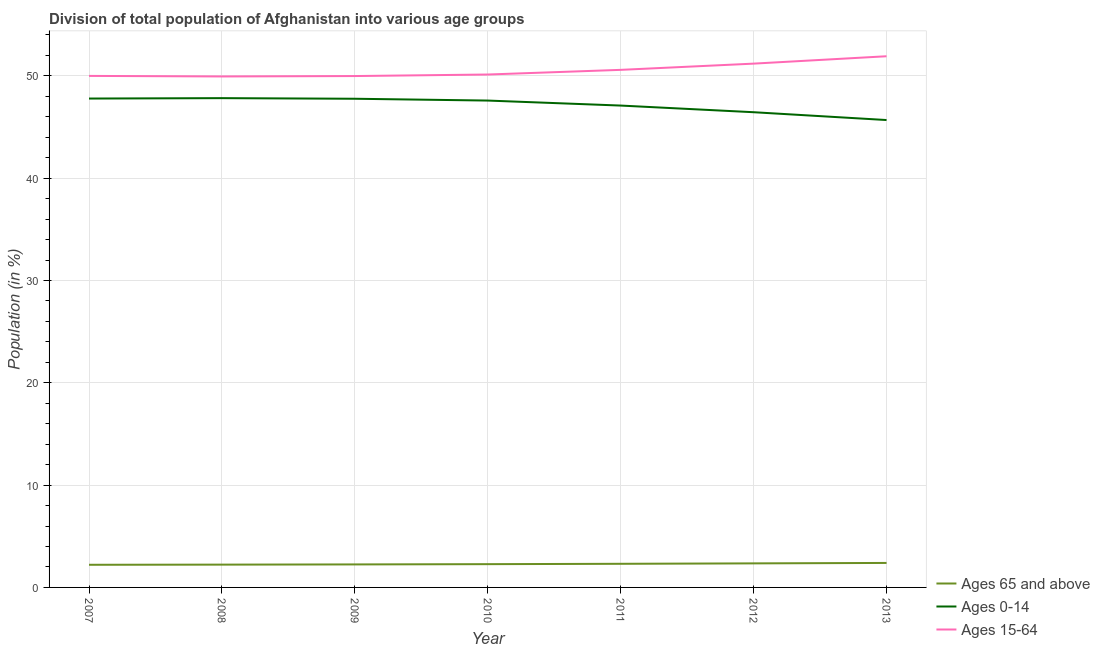How many different coloured lines are there?
Make the answer very short. 3. Does the line corresponding to percentage of population within the age-group of 65 and above intersect with the line corresponding to percentage of population within the age-group 15-64?
Provide a succinct answer. No. Is the number of lines equal to the number of legend labels?
Keep it short and to the point. Yes. What is the percentage of population within the age-group 15-64 in 2007?
Keep it short and to the point. 50. Across all years, what is the maximum percentage of population within the age-group of 65 and above?
Ensure brevity in your answer.  2.39. Across all years, what is the minimum percentage of population within the age-group of 65 and above?
Make the answer very short. 2.21. In which year was the percentage of population within the age-group of 65 and above minimum?
Offer a terse response. 2007. What is the total percentage of population within the age-group 15-64 in the graph?
Provide a short and direct response. 353.78. What is the difference between the percentage of population within the age-group 15-64 in 2009 and that in 2011?
Your answer should be very brief. -0.61. What is the difference between the percentage of population within the age-group 15-64 in 2012 and the percentage of population within the age-group 0-14 in 2010?
Your answer should be very brief. 3.61. What is the average percentage of population within the age-group 0-14 per year?
Your answer should be compact. 47.17. In the year 2011, what is the difference between the percentage of population within the age-group of 65 and above and percentage of population within the age-group 15-64?
Provide a short and direct response. -48.28. In how many years, is the percentage of population within the age-group 0-14 greater than 30 %?
Offer a terse response. 7. What is the ratio of the percentage of population within the age-group 0-14 in 2009 to that in 2012?
Offer a terse response. 1.03. Is the percentage of population within the age-group 0-14 in 2009 less than that in 2011?
Offer a terse response. No. Is the difference between the percentage of population within the age-group of 65 and above in 2007 and 2008 greater than the difference between the percentage of population within the age-group 15-64 in 2007 and 2008?
Give a very brief answer. No. What is the difference between the highest and the second highest percentage of population within the age-group 0-14?
Give a very brief answer. 0.04. What is the difference between the highest and the lowest percentage of population within the age-group of 65 and above?
Offer a terse response. 0.18. In how many years, is the percentage of population within the age-group of 65 and above greater than the average percentage of population within the age-group of 65 and above taken over all years?
Provide a succinct answer. 3. Is the sum of the percentage of population within the age-group 15-64 in 2010 and 2011 greater than the maximum percentage of population within the age-group 0-14 across all years?
Keep it short and to the point. Yes. Is it the case that in every year, the sum of the percentage of population within the age-group of 65 and above and percentage of population within the age-group 0-14 is greater than the percentage of population within the age-group 15-64?
Provide a succinct answer. No. Is the percentage of population within the age-group of 65 and above strictly greater than the percentage of population within the age-group 15-64 over the years?
Provide a short and direct response. No. How many lines are there?
Your answer should be compact. 3. How many years are there in the graph?
Provide a short and direct response. 7. Are the values on the major ticks of Y-axis written in scientific E-notation?
Keep it short and to the point. No. Does the graph contain any zero values?
Give a very brief answer. No. Where does the legend appear in the graph?
Provide a succinct answer. Bottom right. What is the title of the graph?
Offer a very short reply. Division of total population of Afghanistan into various age groups
. Does "Tertiary education" appear as one of the legend labels in the graph?
Provide a short and direct response. No. What is the label or title of the X-axis?
Your answer should be compact. Year. What is the label or title of the Y-axis?
Your answer should be very brief. Population (in %). What is the Population (in %) in Ages 65 and above in 2007?
Provide a succinct answer. 2.21. What is the Population (in %) in Ages 0-14 in 2007?
Provide a succinct answer. 47.79. What is the Population (in %) of Ages 15-64 in 2007?
Offer a very short reply. 50. What is the Population (in %) in Ages 65 and above in 2008?
Offer a terse response. 2.23. What is the Population (in %) of Ages 0-14 in 2008?
Your answer should be very brief. 47.83. What is the Population (in %) of Ages 15-64 in 2008?
Provide a short and direct response. 49.95. What is the Population (in %) of Ages 65 and above in 2009?
Your answer should be compact. 2.25. What is the Population (in %) in Ages 0-14 in 2009?
Give a very brief answer. 47.77. What is the Population (in %) in Ages 15-64 in 2009?
Make the answer very short. 49.98. What is the Population (in %) of Ages 65 and above in 2010?
Keep it short and to the point. 2.28. What is the Population (in %) of Ages 0-14 in 2010?
Provide a succinct answer. 47.59. What is the Population (in %) in Ages 15-64 in 2010?
Give a very brief answer. 50.14. What is the Population (in %) of Ages 65 and above in 2011?
Your response must be concise. 2.31. What is the Population (in %) of Ages 0-14 in 2011?
Make the answer very short. 47.1. What is the Population (in %) in Ages 15-64 in 2011?
Provide a short and direct response. 50.59. What is the Population (in %) in Ages 65 and above in 2012?
Make the answer very short. 2.35. What is the Population (in %) in Ages 0-14 in 2012?
Provide a short and direct response. 46.45. What is the Population (in %) of Ages 15-64 in 2012?
Your answer should be compact. 51.2. What is the Population (in %) in Ages 65 and above in 2013?
Offer a very short reply. 2.39. What is the Population (in %) in Ages 0-14 in 2013?
Ensure brevity in your answer.  45.69. What is the Population (in %) in Ages 15-64 in 2013?
Your response must be concise. 51.92. Across all years, what is the maximum Population (in %) of Ages 65 and above?
Ensure brevity in your answer.  2.39. Across all years, what is the maximum Population (in %) of Ages 0-14?
Your response must be concise. 47.83. Across all years, what is the maximum Population (in %) in Ages 15-64?
Your answer should be compact. 51.92. Across all years, what is the minimum Population (in %) of Ages 65 and above?
Keep it short and to the point. 2.21. Across all years, what is the minimum Population (in %) of Ages 0-14?
Give a very brief answer. 45.69. Across all years, what is the minimum Population (in %) in Ages 15-64?
Provide a short and direct response. 49.95. What is the total Population (in %) of Ages 65 and above in the graph?
Provide a succinct answer. 16.02. What is the total Population (in %) of Ages 0-14 in the graph?
Your answer should be compact. 330.2. What is the total Population (in %) in Ages 15-64 in the graph?
Make the answer very short. 353.78. What is the difference between the Population (in %) of Ages 65 and above in 2007 and that in 2008?
Give a very brief answer. -0.02. What is the difference between the Population (in %) in Ages 0-14 in 2007 and that in 2008?
Ensure brevity in your answer.  -0.04. What is the difference between the Population (in %) of Ages 15-64 in 2007 and that in 2008?
Ensure brevity in your answer.  0.05. What is the difference between the Population (in %) in Ages 65 and above in 2007 and that in 2009?
Provide a short and direct response. -0.04. What is the difference between the Population (in %) of Ages 0-14 in 2007 and that in 2009?
Offer a very short reply. 0.02. What is the difference between the Population (in %) in Ages 15-64 in 2007 and that in 2009?
Offer a terse response. 0.01. What is the difference between the Population (in %) in Ages 65 and above in 2007 and that in 2010?
Keep it short and to the point. -0.06. What is the difference between the Population (in %) in Ages 0-14 in 2007 and that in 2010?
Your answer should be very brief. 0.2. What is the difference between the Population (in %) of Ages 15-64 in 2007 and that in 2010?
Provide a succinct answer. -0.14. What is the difference between the Population (in %) of Ages 65 and above in 2007 and that in 2011?
Keep it short and to the point. -0.1. What is the difference between the Population (in %) of Ages 0-14 in 2007 and that in 2011?
Provide a short and direct response. 0.69. What is the difference between the Population (in %) of Ages 15-64 in 2007 and that in 2011?
Your answer should be compact. -0.59. What is the difference between the Population (in %) in Ages 65 and above in 2007 and that in 2012?
Make the answer very short. -0.14. What is the difference between the Population (in %) of Ages 0-14 in 2007 and that in 2012?
Provide a succinct answer. 1.34. What is the difference between the Population (in %) in Ages 65 and above in 2007 and that in 2013?
Keep it short and to the point. -0.18. What is the difference between the Population (in %) in Ages 0-14 in 2007 and that in 2013?
Provide a succinct answer. 2.1. What is the difference between the Population (in %) in Ages 15-64 in 2007 and that in 2013?
Offer a terse response. -1.92. What is the difference between the Population (in %) in Ages 65 and above in 2008 and that in 2009?
Keep it short and to the point. -0.02. What is the difference between the Population (in %) in Ages 0-14 in 2008 and that in 2009?
Provide a short and direct response. 0.06. What is the difference between the Population (in %) in Ages 15-64 in 2008 and that in 2009?
Offer a terse response. -0.04. What is the difference between the Population (in %) in Ages 65 and above in 2008 and that in 2010?
Give a very brief answer. -0.05. What is the difference between the Population (in %) in Ages 0-14 in 2008 and that in 2010?
Keep it short and to the point. 0.24. What is the difference between the Population (in %) in Ages 15-64 in 2008 and that in 2010?
Your answer should be compact. -0.19. What is the difference between the Population (in %) of Ages 65 and above in 2008 and that in 2011?
Make the answer very short. -0.08. What is the difference between the Population (in %) of Ages 0-14 in 2008 and that in 2011?
Offer a very short reply. 0.72. What is the difference between the Population (in %) of Ages 15-64 in 2008 and that in 2011?
Provide a short and direct response. -0.64. What is the difference between the Population (in %) in Ages 65 and above in 2008 and that in 2012?
Provide a succinct answer. -0.12. What is the difference between the Population (in %) in Ages 0-14 in 2008 and that in 2012?
Give a very brief answer. 1.38. What is the difference between the Population (in %) of Ages 15-64 in 2008 and that in 2012?
Make the answer very short. -1.25. What is the difference between the Population (in %) of Ages 65 and above in 2008 and that in 2013?
Offer a terse response. -0.17. What is the difference between the Population (in %) of Ages 0-14 in 2008 and that in 2013?
Keep it short and to the point. 2.14. What is the difference between the Population (in %) of Ages 15-64 in 2008 and that in 2013?
Your response must be concise. -1.97. What is the difference between the Population (in %) of Ages 65 and above in 2009 and that in 2010?
Your response must be concise. -0.03. What is the difference between the Population (in %) in Ages 0-14 in 2009 and that in 2010?
Offer a very short reply. 0.18. What is the difference between the Population (in %) in Ages 15-64 in 2009 and that in 2010?
Offer a very short reply. -0.15. What is the difference between the Population (in %) of Ages 65 and above in 2009 and that in 2011?
Your response must be concise. -0.06. What is the difference between the Population (in %) in Ages 0-14 in 2009 and that in 2011?
Provide a succinct answer. 0.67. What is the difference between the Population (in %) in Ages 15-64 in 2009 and that in 2011?
Make the answer very short. -0.6. What is the difference between the Population (in %) of Ages 65 and above in 2009 and that in 2012?
Give a very brief answer. -0.1. What is the difference between the Population (in %) in Ages 0-14 in 2009 and that in 2012?
Provide a short and direct response. 1.32. What is the difference between the Population (in %) in Ages 15-64 in 2009 and that in 2012?
Your answer should be very brief. -1.22. What is the difference between the Population (in %) of Ages 65 and above in 2009 and that in 2013?
Your answer should be compact. -0.15. What is the difference between the Population (in %) of Ages 0-14 in 2009 and that in 2013?
Ensure brevity in your answer.  2.08. What is the difference between the Population (in %) of Ages 15-64 in 2009 and that in 2013?
Provide a short and direct response. -1.94. What is the difference between the Population (in %) of Ages 65 and above in 2010 and that in 2011?
Keep it short and to the point. -0.03. What is the difference between the Population (in %) in Ages 0-14 in 2010 and that in 2011?
Ensure brevity in your answer.  0.49. What is the difference between the Population (in %) in Ages 15-64 in 2010 and that in 2011?
Keep it short and to the point. -0.45. What is the difference between the Population (in %) of Ages 65 and above in 2010 and that in 2012?
Provide a succinct answer. -0.08. What is the difference between the Population (in %) in Ages 0-14 in 2010 and that in 2012?
Your answer should be very brief. 1.14. What is the difference between the Population (in %) in Ages 15-64 in 2010 and that in 2012?
Provide a short and direct response. -1.06. What is the difference between the Population (in %) in Ages 65 and above in 2010 and that in 2013?
Offer a very short reply. -0.12. What is the difference between the Population (in %) in Ages 0-14 in 2010 and that in 2013?
Keep it short and to the point. 1.9. What is the difference between the Population (in %) of Ages 15-64 in 2010 and that in 2013?
Your answer should be very brief. -1.78. What is the difference between the Population (in %) of Ages 65 and above in 2011 and that in 2012?
Provide a succinct answer. -0.04. What is the difference between the Population (in %) in Ages 0-14 in 2011 and that in 2012?
Your response must be concise. 0.65. What is the difference between the Population (in %) in Ages 15-64 in 2011 and that in 2012?
Ensure brevity in your answer.  -0.61. What is the difference between the Population (in %) in Ages 65 and above in 2011 and that in 2013?
Provide a short and direct response. -0.08. What is the difference between the Population (in %) in Ages 0-14 in 2011 and that in 2013?
Ensure brevity in your answer.  1.42. What is the difference between the Population (in %) in Ages 15-64 in 2011 and that in 2013?
Your answer should be compact. -1.33. What is the difference between the Population (in %) of Ages 65 and above in 2012 and that in 2013?
Offer a terse response. -0.04. What is the difference between the Population (in %) of Ages 0-14 in 2012 and that in 2013?
Provide a short and direct response. 0.76. What is the difference between the Population (in %) of Ages 15-64 in 2012 and that in 2013?
Your answer should be very brief. -0.72. What is the difference between the Population (in %) of Ages 65 and above in 2007 and the Population (in %) of Ages 0-14 in 2008?
Offer a terse response. -45.61. What is the difference between the Population (in %) of Ages 65 and above in 2007 and the Population (in %) of Ages 15-64 in 2008?
Make the answer very short. -47.73. What is the difference between the Population (in %) in Ages 0-14 in 2007 and the Population (in %) in Ages 15-64 in 2008?
Give a very brief answer. -2.16. What is the difference between the Population (in %) of Ages 65 and above in 2007 and the Population (in %) of Ages 0-14 in 2009?
Ensure brevity in your answer.  -45.55. What is the difference between the Population (in %) in Ages 65 and above in 2007 and the Population (in %) in Ages 15-64 in 2009?
Your response must be concise. -47.77. What is the difference between the Population (in %) in Ages 0-14 in 2007 and the Population (in %) in Ages 15-64 in 2009?
Ensure brevity in your answer.  -2.2. What is the difference between the Population (in %) in Ages 65 and above in 2007 and the Population (in %) in Ages 0-14 in 2010?
Offer a very short reply. -45.38. What is the difference between the Population (in %) of Ages 65 and above in 2007 and the Population (in %) of Ages 15-64 in 2010?
Give a very brief answer. -47.92. What is the difference between the Population (in %) in Ages 0-14 in 2007 and the Population (in %) in Ages 15-64 in 2010?
Give a very brief answer. -2.35. What is the difference between the Population (in %) of Ages 65 and above in 2007 and the Population (in %) of Ages 0-14 in 2011?
Offer a terse response. -44.89. What is the difference between the Population (in %) of Ages 65 and above in 2007 and the Population (in %) of Ages 15-64 in 2011?
Your answer should be compact. -48.38. What is the difference between the Population (in %) in Ages 0-14 in 2007 and the Population (in %) in Ages 15-64 in 2011?
Your answer should be very brief. -2.8. What is the difference between the Population (in %) in Ages 65 and above in 2007 and the Population (in %) in Ages 0-14 in 2012?
Offer a very short reply. -44.24. What is the difference between the Population (in %) of Ages 65 and above in 2007 and the Population (in %) of Ages 15-64 in 2012?
Offer a very short reply. -48.99. What is the difference between the Population (in %) of Ages 0-14 in 2007 and the Population (in %) of Ages 15-64 in 2012?
Your response must be concise. -3.41. What is the difference between the Population (in %) of Ages 65 and above in 2007 and the Population (in %) of Ages 0-14 in 2013?
Your answer should be compact. -43.47. What is the difference between the Population (in %) in Ages 65 and above in 2007 and the Population (in %) in Ages 15-64 in 2013?
Offer a terse response. -49.71. What is the difference between the Population (in %) in Ages 0-14 in 2007 and the Population (in %) in Ages 15-64 in 2013?
Keep it short and to the point. -4.13. What is the difference between the Population (in %) of Ages 65 and above in 2008 and the Population (in %) of Ages 0-14 in 2009?
Give a very brief answer. -45.54. What is the difference between the Population (in %) in Ages 65 and above in 2008 and the Population (in %) in Ages 15-64 in 2009?
Make the answer very short. -47.76. What is the difference between the Population (in %) of Ages 0-14 in 2008 and the Population (in %) of Ages 15-64 in 2009?
Your response must be concise. -2.16. What is the difference between the Population (in %) in Ages 65 and above in 2008 and the Population (in %) in Ages 0-14 in 2010?
Make the answer very short. -45.36. What is the difference between the Population (in %) in Ages 65 and above in 2008 and the Population (in %) in Ages 15-64 in 2010?
Make the answer very short. -47.91. What is the difference between the Population (in %) of Ages 0-14 in 2008 and the Population (in %) of Ages 15-64 in 2010?
Your answer should be very brief. -2.31. What is the difference between the Population (in %) of Ages 65 and above in 2008 and the Population (in %) of Ages 0-14 in 2011?
Your answer should be very brief. -44.87. What is the difference between the Population (in %) in Ages 65 and above in 2008 and the Population (in %) in Ages 15-64 in 2011?
Offer a terse response. -48.36. What is the difference between the Population (in %) of Ages 0-14 in 2008 and the Population (in %) of Ages 15-64 in 2011?
Provide a short and direct response. -2.76. What is the difference between the Population (in %) of Ages 65 and above in 2008 and the Population (in %) of Ages 0-14 in 2012?
Keep it short and to the point. -44.22. What is the difference between the Population (in %) in Ages 65 and above in 2008 and the Population (in %) in Ages 15-64 in 2012?
Make the answer very short. -48.97. What is the difference between the Population (in %) in Ages 0-14 in 2008 and the Population (in %) in Ages 15-64 in 2012?
Offer a very short reply. -3.37. What is the difference between the Population (in %) of Ages 65 and above in 2008 and the Population (in %) of Ages 0-14 in 2013?
Ensure brevity in your answer.  -43.46. What is the difference between the Population (in %) of Ages 65 and above in 2008 and the Population (in %) of Ages 15-64 in 2013?
Provide a short and direct response. -49.69. What is the difference between the Population (in %) in Ages 0-14 in 2008 and the Population (in %) in Ages 15-64 in 2013?
Your response must be concise. -4.1. What is the difference between the Population (in %) of Ages 65 and above in 2009 and the Population (in %) of Ages 0-14 in 2010?
Make the answer very short. -45.34. What is the difference between the Population (in %) of Ages 65 and above in 2009 and the Population (in %) of Ages 15-64 in 2010?
Your response must be concise. -47.89. What is the difference between the Population (in %) in Ages 0-14 in 2009 and the Population (in %) in Ages 15-64 in 2010?
Make the answer very short. -2.37. What is the difference between the Population (in %) of Ages 65 and above in 2009 and the Population (in %) of Ages 0-14 in 2011?
Offer a terse response. -44.85. What is the difference between the Population (in %) of Ages 65 and above in 2009 and the Population (in %) of Ages 15-64 in 2011?
Provide a succinct answer. -48.34. What is the difference between the Population (in %) in Ages 0-14 in 2009 and the Population (in %) in Ages 15-64 in 2011?
Ensure brevity in your answer.  -2.82. What is the difference between the Population (in %) of Ages 65 and above in 2009 and the Population (in %) of Ages 0-14 in 2012?
Provide a short and direct response. -44.2. What is the difference between the Population (in %) in Ages 65 and above in 2009 and the Population (in %) in Ages 15-64 in 2012?
Make the answer very short. -48.95. What is the difference between the Population (in %) of Ages 0-14 in 2009 and the Population (in %) of Ages 15-64 in 2012?
Your answer should be compact. -3.43. What is the difference between the Population (in %) of Ages 65 and above in 2009 and the Population (in %) of Ages 0-14 in 2013?
Your response must be concise. -43.44. What is the difference between the Population (in %) of Ages 65 and above in 2009 and the Population (in %) of Ages 15-64 in 2013?
Your response must be concise. -49.67. What is the difference between the Population (in %) of Ages 0-14 in 2009 and the Population (in %) of Ages 15-64 in 2013?
Your response must be concise. -4.15. What is the difference between the Population (in %) in Ages 65 and above in 2010 and the Population (in %) in Ages 0-14 in 2011?
Make the answer very short. -44.83. What is the difference between the Population (in %) in Ages 65 and above in 2010 and the Population (in %) in Ages 15-64 in 2011?
Your answer should be very brief. -48.31. What is the difference between the Population (in %) in Ages 0-14 in 2010 and the Population (in %) in Ages 15-64 in 2011?
Your response must be concise. -3. What is the difference between the Population (in %) of Ages 65 and above in 2010 and the Population (in %) of Ages 0-14 in 2012?
Offer a very short reply. -44.17. What is the difference between the Population (in %) of Ages 65 and above in 2010 and the Population (in %) of Ages 15-64 in 2012?
Make the answer very short. -48.92. What is the difference between the Population (in %) of Ages 0-14 in 2010 and the Population (in %) of Ages 15-64 in 2012?
Your answer should be very brief. -3.61. What is the difference between the Population (in %) in Ages 65 and above in 2010 and the Population (in %) in Ages 0-14 in 2013?
Provide a short and direct response. -43.41. What is the difference between the Population (in %) of Ages 65 and above in 2010 and the Population (in %) of Ages 15-64 in 2013?
Give a very brief answer. -49.65. What is the difference between the Population (in %) of Ages 0-14 in 2010 and the Population (in %) of Ages 15-64 in 2013?
Your answer should be very brief. -4.33. What is the difference between the Population (in %) in Ages 65 and above in 2011 and the Population (in %) in Ages 0-14 in 2012?
Offer a terse response. -44.14. What is the difference between the Population (in %) in Ages 65 and above in 2011 and the Population (in %) in Ages 15-64 in 2012?
Give a very brief answer. -48.89. What is the difference between the Population (in %) in Ages 0-14 in 2011 and the Population (in %) in Ages 15-64 in 2012?
Give a very brief answer. -4.1. What is the difference between the Population (in %) of Ages 65 and above in 2011 and the Population (in %) of Ages 0-14 in 2013?
Keep it short and to the point. -43.38. What is the difference between the Population (in %) of Ages 65 and above in 2011 and the Population (in %) of Ages 15-64 in 2013?
Make the answer very short. -49.61. What is the difference between the Population (in %) of Ages 0-14 in 2011 and the Population (in %) of Ages 15-64 in 2013?
Your response must be concise. -4.82. What is the difference between the Population (in %) in Ages 65 and above in 2012 and the Population (in %) in Ages 0-14 in 2013?
Provide a short and direct response. -43.33. What is the difference between the Population (in %) of Ages 65 and above in 2012 and the Population (in %) of Ages 15-64 in 2013?
Give a very brief answer. -49.57. What is the difference between the Population (in %) in Ages 0-14 in 2012 and the Population (in %) in Ages 15-64 in 2013?
Provide a short and direct response. -5.47. What is the average Population (in %) in Ages 65 and above per year?
Offer a terse response. 2.29. What is the average Population (in %) in Ages 0-14 per year?
Your answer should be very brief. 47.17. What is the average Population (in %) of Ages 15-64 per year?
Provide a short and direct response. 50.54. In the year 2007, what is the difference between the Population (in %) of Ages 65 and above and Population (in %) of Ages 0-14?
Give a very brief answer. -45.57. In the year 2007, what is the difference between the Population (in %) of Ages 65 and above and Population (in %) of Ages 15-64?
Your answer should be compact. -47.79. In the year 2007, what is the difference between the Population (in %) of Ages 0-14 and Population (in %) of Ages 15-64?
Make the answer very short. -2.21. In the year 2008, what is the difference between the Population (in %) in Ages 65 and above and Population (in %) in Ages 0-14?
Your response must be concise. -45.6. In the year 2008, what is the difference between the Population (in %) of Ages 65 and above and Population (in %) of Ages 15-64?
Your response must be concise. -47.72. In the year 2008, what is the difference between the Population (in %) in Ages 0-14 and Population (in %) in Ages 15-64?
Give a very brief answer. -2.12. In the year 2009, what is the difference between the Population (in %) in Ages 65 and above and Population (in %) in Ages 0-14?
Make the answer very short. -45.52. In the year 2009, what is the difference between the Population (in %) in Ages 65 and above and Population (in %) in Ages 15-64?
Offer a very short reply. -47.74. In the year 2009, what is the difference between the Population (in %) in Ages 0-14 and Population (in %) in Ages 15-64?
Offer a very short reply. -2.22. In the year 2010, what is the difference between the Population (in %) of Ages 65 and above and Population (in %) of Ages 0-14?
Keep it short and to the point. -45.31. In the year 2010, what is the difference between the Population (in %) of Ages 65 and above and Population (in %) of Ages 15-64?
Your answer should be very brief. -47.86. In the year 2010, what is the difference between the Population (in %) in Ages 0-14 and Population (in %) in Ages 15-64?
Give a very brief answer. -2.55. In the year 2011, what is the difference between the Population (in %) of Ages 65 and above and Population (in %) of Ages 0-14?
Your response must be concise. -44.79. In the year 2011, what is the difference between the Population (in %) in Ages 65 and above and Population (in %) in Ages 15-64?
Ensure brevity in your answer.  -48.28. In the year 2011, what is the difference between the Population (in %) in Ages 0-14 and Population (in %) in Ages 15-64?
Make the answer very short. -3.49. In the year 2012, what is the difference between the Population (in %) of Ages 65 and above and Population (in %) of Ages 0-14?
Your response must be concise. -44.1. In the year 2012, what is the difference between the Population (in %) in Ages 65 and above and Population (in %) in Ages 15-64?
Your answer should be compact. -48.85. In the year 2012, what is the difference between the Population (in %) in Ages 0-14 and Population (in %) in Ages 15-64?
Keep it short and to the point. -4.75. In the year 2013, what is the difference between the Population (in %) in Ages 65 and above and Population (in %) in Ages 0-14?
Your response must be concise. -43.29. In the year 2013, what is the difference between the Population (in %) of Ages 65 and above and Population (in %) of Ages 15-64?
Your response must be concise. -49.53. In the year 2013, what is the difference between the Population (in %) of Ages 0-14 and Population (in %) of Ages 15-64?
Give a very brief answer. -6.24. What is the ratio of the Population (in %) in Ages 65 and above in 2007 to that in 2008?
Ensure brevity in your answer.  0.99. What is the ratio of the Population (in %) in Ages 0-14 in 2007 to that in 2008?
Offer a very short reply. 1. What is the ratio of the Population (in %) of Ages 65 and above in 2007 to that in 2009?
Give a very brief answer. 0.98. What is the ratio of the Population (in %) of Ages 65 and above in 2007 to that in 2010?
Make the answer very short. 0.97. What is the ratio of the Population (in %) in Ages 65 and above in 2007 to that in 2011?
Keep it short and to the point. 0.96. What is the ratio of the Population (in %) in Ages 0-14 in 2007 to that in 2011?
Provide a succinct answer. 1.01. What is the ratio of the Population (in %) in Ages 15-64 in 2007 to that in 2011?
Your answer should be very brief. 0.99. What is the ratio of the Population (in %) in Ages 65 and above in 2007 to that in 2012?
Make the answer very short. 0.94. What is the ratio of the Population (in %) of Ages 0-14 in 2007 to that in 2012?
Make the answer very short. 1.03. What is the ratio of the Population (in %) of Ages 15-64 in 2007 to that in 2012?
Give a very brief answer. 0.98. What is the ratio of the Population (in %) of Ages 65 and above in 2007 to that in 2013?
Provide a succinct answer. 0.92. What is the ratio of the Population (in %) in Ages 0-14 in 2007 to that in 2013?
Provide a short and direct response. 1.05. What is the ratio of the Population (in %) of Ages 15-64 in 2007 to that in 2013?
Make the answer very short. 0.96. What is the ratio of the Population (in %) of Ages 65 and above in 2008 to that in 2009?
Your answer should be compact. 0.99. What is the ratio of the Population (in %) in Ages 0-14 in 2008 to that in 2009?
Your response must be concise. 1. What is the ratio of the Population (in %) of Ages 15-64 in 2008 to that in 2009?
Ensure brevity in your answer.  1. What is the ratio of the Population (in %) of Ages 65 and above in 2008 to that in 2010?
Your answer should be very brief. 0.98. What is the ratio of the Population (in %) of Ages 65 and above in 2008 to that in 2011?
Your response must be concise. 0.96. What is the ratio of the Population (in %) in Ages 0-14 in 2008 to that in 2011?
Your answer should be very brief. 1.02. What is the ratio of the Population (in %) in Ages 15-64 in 2008 to that in 2011?
Offer a very short reply. 0.99. What is the ratio of the Population (in %) in Ages 65 and above in 2008 to that in 2012?
Give a very brief answer. 0.95. What is the ratio of the Population (in %) in Ages 0-14 in 2008 to that in 2012?
Offer a terse response. 1.03. What is the ratio of the Population (in %) in Ages 15-64 in 2008 to that in 2012?
Make the answer very short. 0.98. What is the ratio of the Population (in %) in Ages 65 and above in 2008 to that in 2013?
Make the answer very short. 0.93. What is the ratio of the Population (in %) of Ages 0-14 in 2008 to that in 2013?
Your response must be concise. 1.05. What is the ratio of the Population (in %) in Ages 0-14 in 2009 to that in 2010?
Keep it short and to the point. 1. What is the ratio of the Population (in %) of Ages 15-64 in 2009 to that in 2010?
Make the answer very short. 1. What is the ratio of the Population (in %) in Ages 65 and above in 2009 to that in 2011?
Provide a succinct answer. 0.97. What is the ratio of the Population (in %) of Ages 0-14 in 2009 to that in 2011?
Give a very brief answer. 1.01. What is the ratio of the Population (in %) in Ages 15-64 in 2009 to that in 2011?
Give a very brief answer. 0.99. What is the ratio of the Population (in %) of Ages 65 and above in 2009 to that in 2012?
Offer a very short reply. 0.96. What is the ratio of the Population (in %) of Ages 0-14 in 2009 to that in 2012?
Your answer should be compact. 1.03. What is the ratio of the Population (in %) in Ages 15-64 in 2009 to that in 2012?
Your answer should be very brief. 0.98. What is the ratio of the Population (in %) in Ages 65 and above in 2009 to that in 2013?
Give a very brief answer. 0.94. What is the ratio of the Population (in %) of Ages 0-14 in 2009 to that in 2013?
Offer a terse response. 1.05. What is the ratio of the Population (in %) in Ages 15-64 in 2009 to that in 2013?
Provide a succinct answer. 0.96. What is the ratio of the Population (in %) in Ages 65 and above in 2010 to that in 2011?
Provide a succinct answer. 0.99. What is the ratio of the Population (in %) of Ages 0-14 in 2010 to that in 2011?
Keep it short and to the point. 1.01. What is the ratio of the Population (in %) in Ages 15-64 in 2010 to that in 2011?
Keep it short and to the point. 0.99. What is the ratio of the Population (in %) in Ages 65 and above in 2010 to that in 2012?
Provide a succinct answer. 0.97. What is the ratio of the Population (in %) in Ages 0-14 in 2010 to that in 2012?
Offer a very short reply. 1.02. What is the ratio of the Population (in %) of Ages 15-64 in 2010 to that in 2012?
Make the answer very short. 0.98. What is the ratio of the Population (in %) of Ages 65 and above in 2010 to that in 2013?
Provide a short and direct response. 0.95. What is the ratio of the Population (in %) of Ages 0-14 in 2010 to that in 2013?
Provide a short and direct response. 1.04. What is the ratio of the Population (in %) of Ages 15-64 in 2010 to that in 2013?
Provide a short and direct response. 0.97. What is the ratio of the Population (in %) in Ages 65 and above in 2011 to that in 2012?
Offer a terse response. 0.98. What is the ratio of the Population (in %) in Ages 15-64 in 2011 to that in 2012?
Offer a terse response. 0.99. What is the ratio of the Population (in %) in Ages 65 and above in 2011 to that in 2013?
Keep it short and to the point. 0.96. What is the ratio of the Population (in %) in Ages 0-14 in 2011 to that in 2013?
Your response must be concise. 1.03. What is the ratio of the Population (in %) in Ages 15-64 in 2011 to that in 2013?
Make the answer very short. 0.97. What is the ratio of the Population (in %) of Ages 65 and above in 2012 to that in 2013?
Your answer should be very brief. 0.98. What is the ratio of the Population (in %) of Ages 0-14 in 2012 to that in 2013?
Keep it short and to the point. 1.02. What is the ratio of the Population (in %) in Ages 15-64 in 2012 to that in 2013?
Provide a succinct answer. 0.99. What is the difference between the highest and the second highest Population (in %) in Ages 65 and above?
Your response must be concise. 0.04. What is the difference between the highest and the second highest Population (in %) in Ages 0-14?
Ensure brevity in your answer.  0.04. What is the difference between the highest and the second highest Population (in %) in Ages 15-64?
Provide a succinct answer. 0.72. What is the difference between the highest and the lowest Population (in %) of Ages 65 and above?
Provide a short and direct response. 0.18. What is the difference between the highest and the lowest Population (in %) in Ages 0-14?
Your response must be concise. 2.14. What is the difference between the highest and the lowest Population (in %) in Ages 15-64?
Offer a terse response. 1.97. 